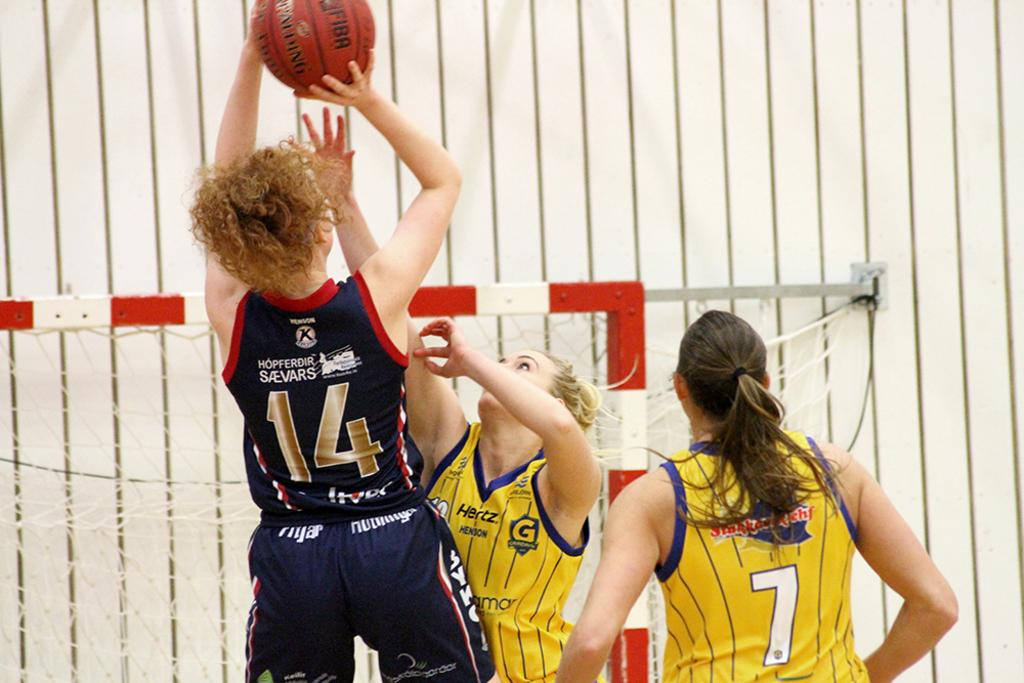<image>
Share a concise interpretation of the image provided. Female basketball players are fighting for the ball and the player with 14 on her jersey is about to score. 